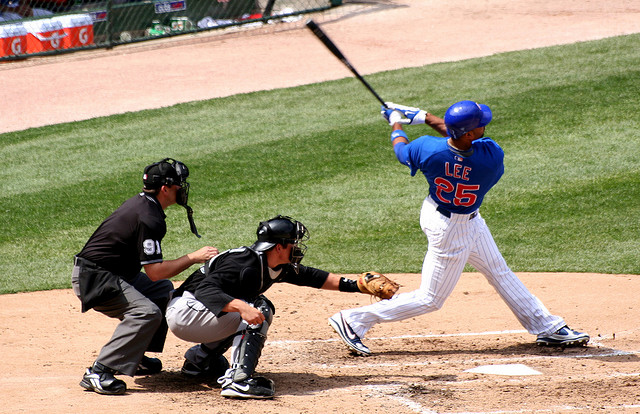Identify the text displayed in this image. LEE 25 9 G 